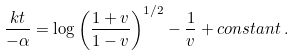Convert formula to latex. <formula><loc_0><loc_0><loc_500><loc_500>\frac { k t } { - \alpha } = \log \left ( \frac { 1 + v } { 1 - v } \right ) ^ { 1 / 2 } - \frac { 1 } { v } + c o n s t a n t \, .</formula> 